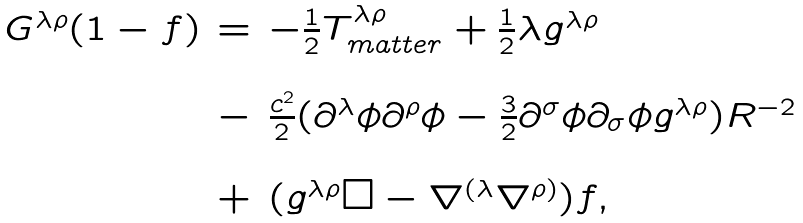Convert formula to latex. <formula><loc_0><loc_0><loc_500><loc_500>\begin{array} { c c l } G ^ { \lambda \rho } ( 1 - f ) & = & - \frac { 1 } { 2 } T ^ { \lambda \rho } _ { m a t t e r } + \frac { 1 } { 2 } \lambda g ^ { \lambda \rho } \\ & & \\ & - & \frac { c ^ { 2 } } { 2 } ( \partial ^ { \lambda } \phi \partial ^ { \rho } \phi - \frac { 3 } { 2 } \partial ^ { \sigma } \phi \partial _ { \sigma } \phi g ^ { \lambda \rho } ) R ^ { - 2 } \\ & & \\ & + & ( g ^ { \lambda \rho } \Box - \nabla ^ { ( \lambda } \nabla ^ { \rho ) } ) f , \end{array}</formula> 